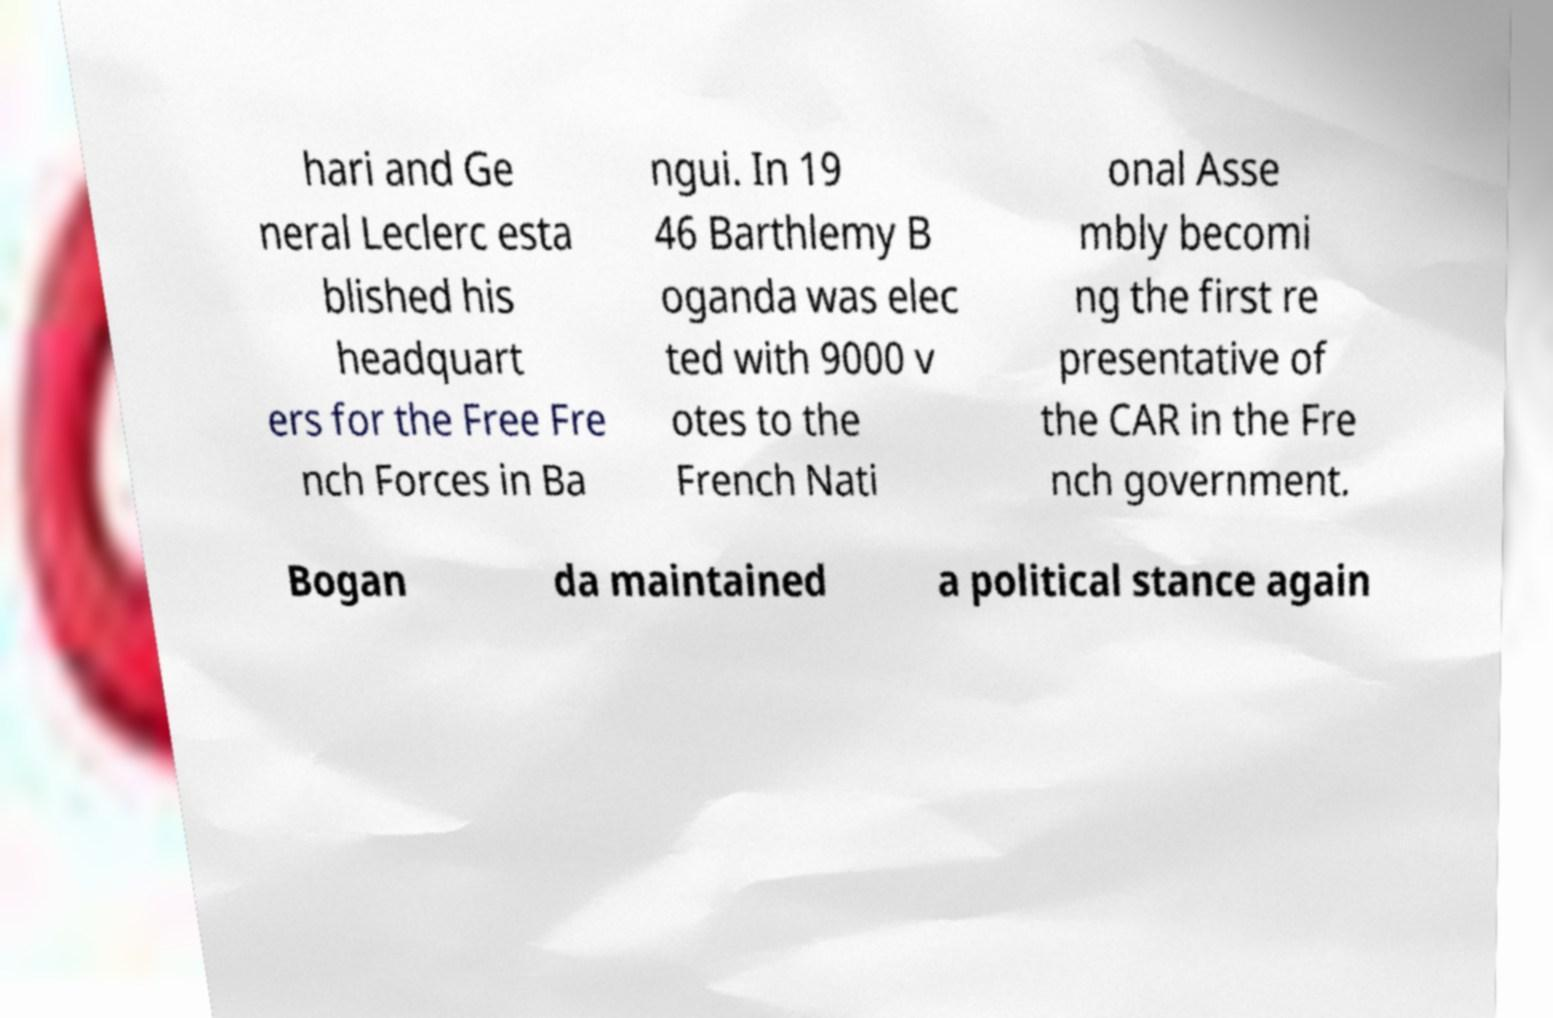I need the written content from this picture converted into text. Can you do that? hari and Ge neral Leclerc esta blished his headquart ers for the Free Fre nch Forces in Ba ngui. In 19 46 Barthlemy B oganda was elec ted with 9000 v otes to the French Nati onal Asse mbly becomi ng the first re presentative of the CAR in the Fre nch government. Bogan da maintained a political stance again 